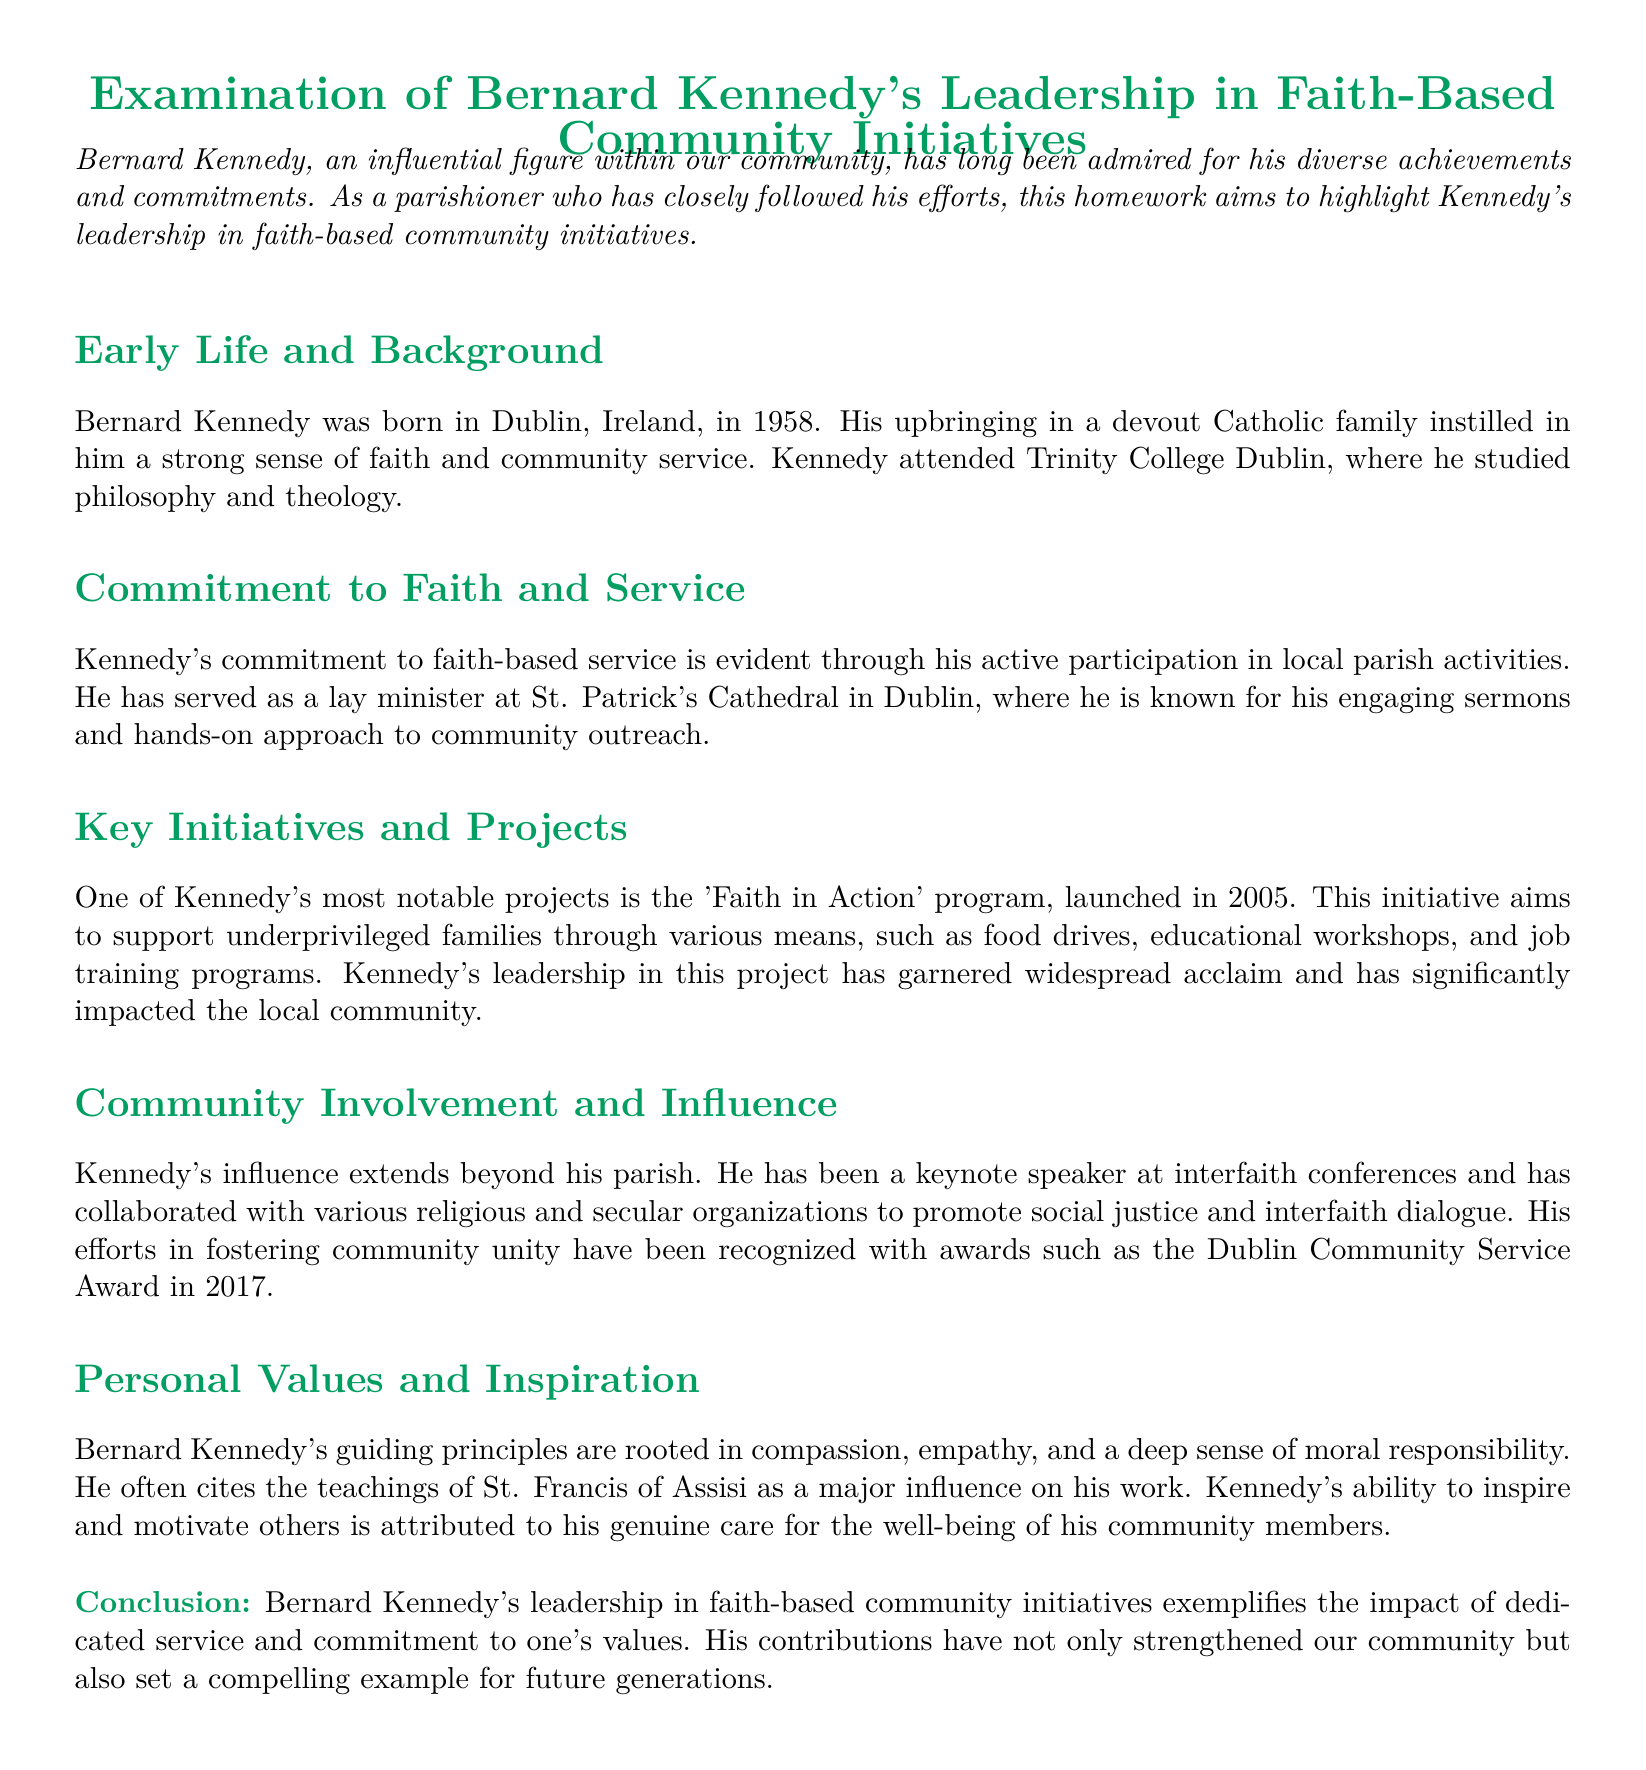what year was Bernard Kennedy born? The document states that Bernard Kennedy was born in 1958.
Answer: 1958 where did Bernard Kennedy study? The document mentions that Bernard Kennedy attended Trinity College Dublin.
Answer: Trinity College Dublin what program did Kennedy launch in 2005? The document highlights the 'Faith in Action' program initiated by Kennedy in 2005.
Answer: 'Faith in Action' program which award did Kennedy receive in 2017? The document indicates that Kennedy received the Dublin Community Service Award in 2017.
Answer: Dublin Community Service Award who is cited as a major influence on Kennedy's work? The document states that Kennedy often cites the teachings of St. Francis of Assisi as a major influence.
Answer: St. Francis of Assisi what is the main focus of the 'Faith in Action' program? The document explains that this program aims to support underprivileged families through various means.
Answer: support underprivileged families how is Kennedy described in his role at St. Patrick's Cathedral? The document mentions that he is known for his engaging sermons and hands-on approach.
Answer: engaging sermons and hands-on approach what are Kennedy's guiding principles? The document outlines his guiding principles as compassion, empathy, and moral responsibility.
Answer: compassion, empathy, moral responsibility what type of initiatives does Kennedy collaborate on? The document indicates that he collaborates with organizations to promote social justice and interfaith dialogue.
Answer: social justice and interfaith dialogue 